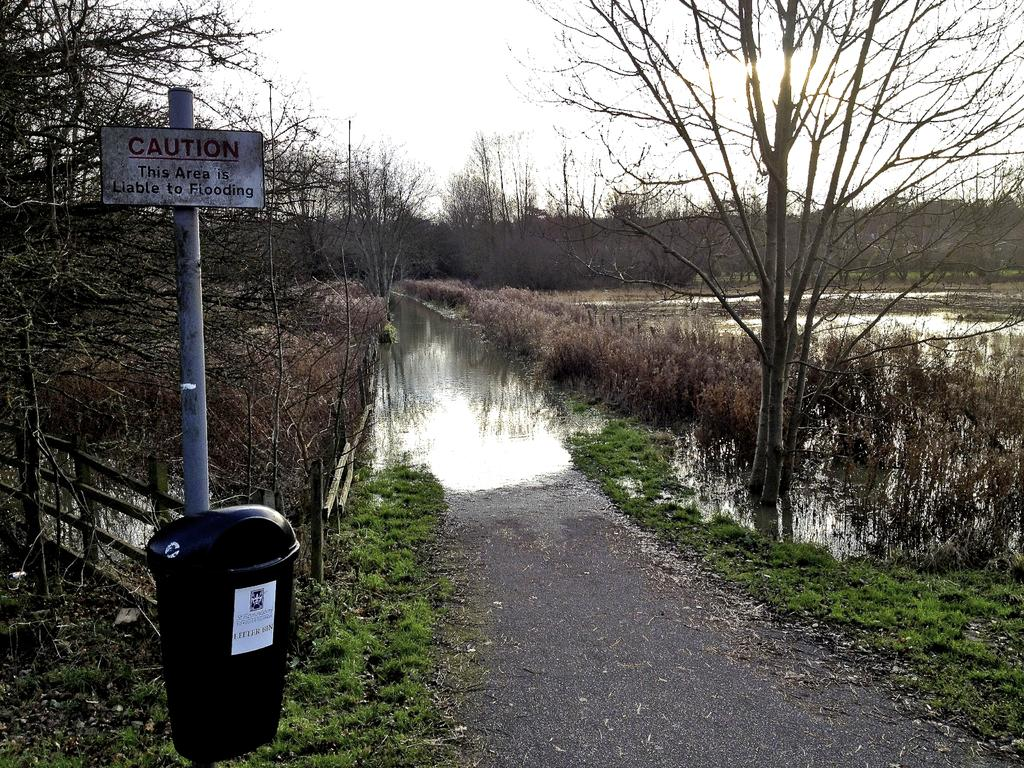<image>
Offer a succinct explanation of the picture presented. a flooded road and field with a sign saying "Caution this area is liable to flooding" 